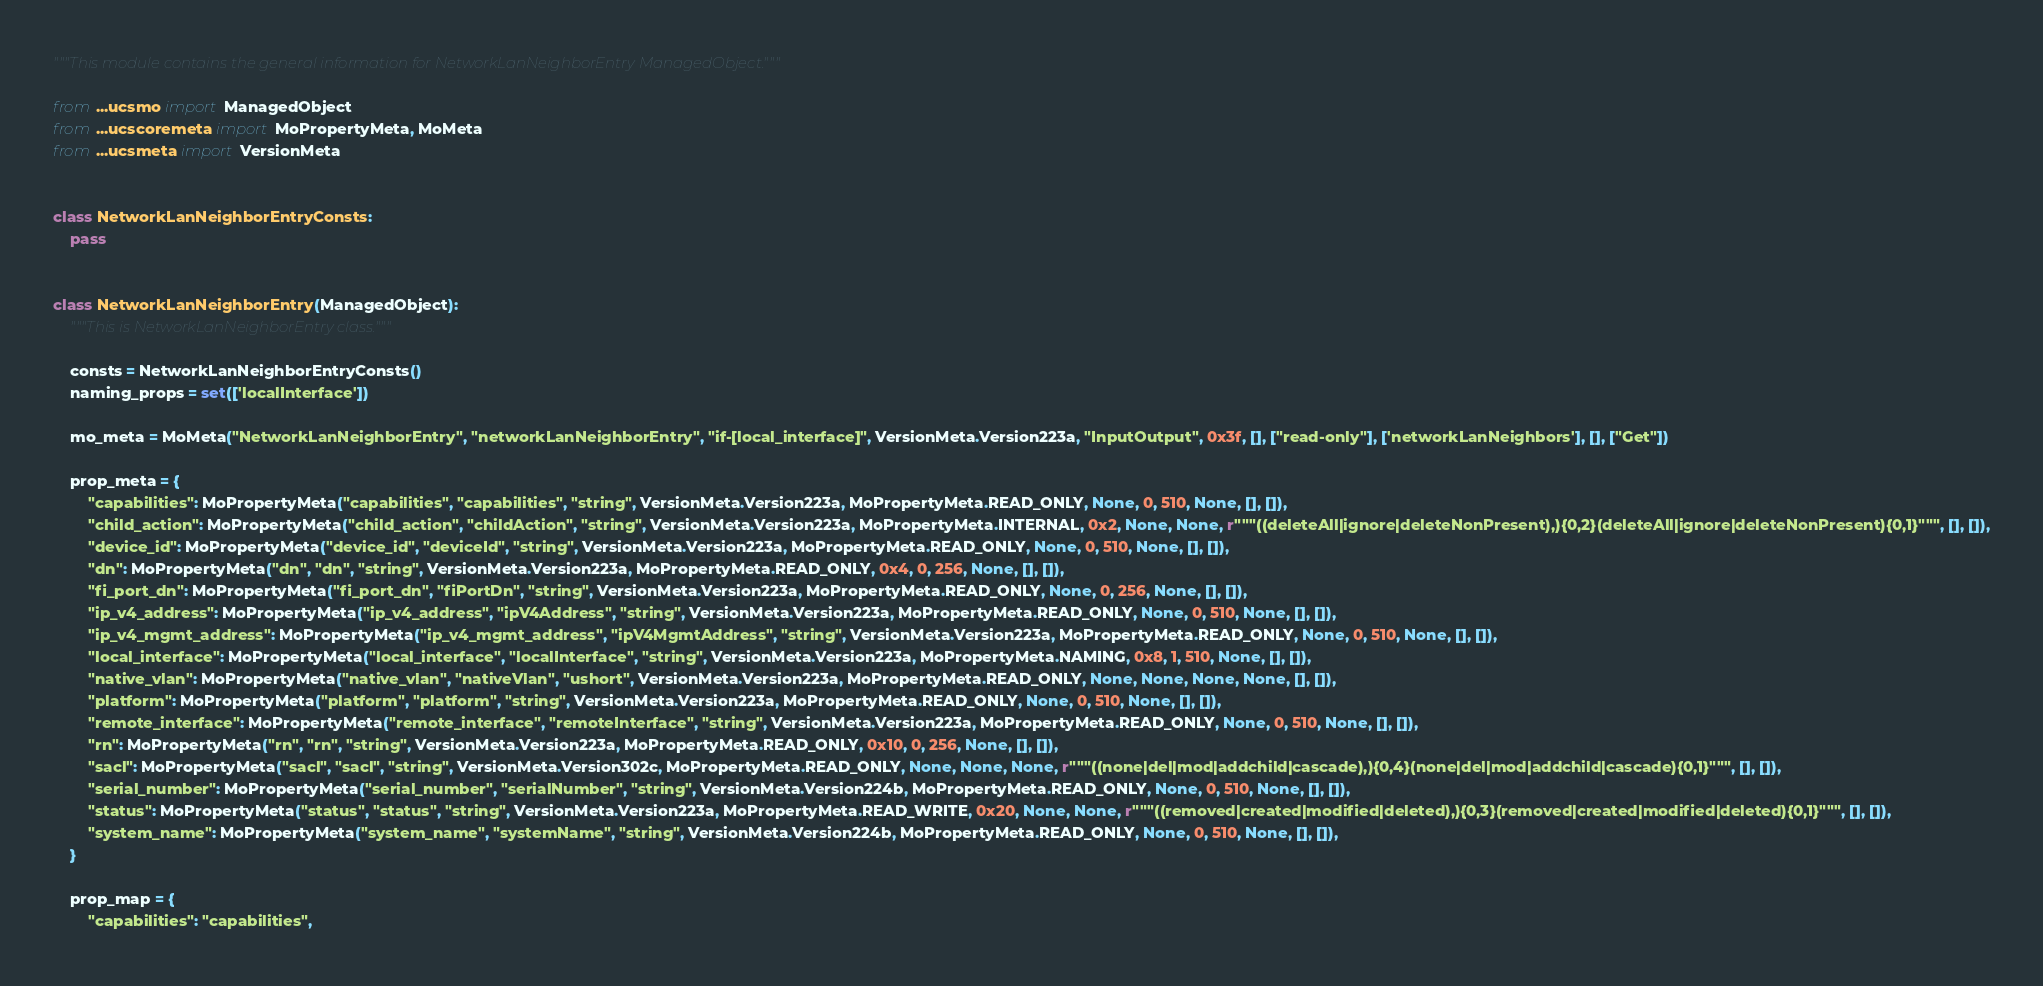<code> <loc_0><loc_0><loc_500><loc_500><_Python_>"""This module contains the general information for NetworkLanNeighborEntry ManagedObject."""

from ...ucsmo import ManagedObject
from ...ucscoremeta import MoPropertyMeta, MoMeta
from ...ucsmeta import VersionMeta


class NetworkLanNeighborEntryConsts:
    pass


class NetworkLanNeighborEntry(ManagedObject):
    """This is NetworkLanNeighborEntry class."""

    consts = NetworkLanNeighborEntryConsts()
    naming_props = set(['localInterface'])

    mo_meta = MoMeta("NetworkLanNeighborEntry", "networkLanNeighborEntry", "if-[local_interface]", VersionMeta.Version223a, "InputOutput", 0x3f, [], ["read-only"], ['networkLanNeighbors'], [], ["Get"])

    prop_meta = {
        "capabilities": MoPropertyMeta("capabilities", "capabilities", "string", VersionMeta.Version223a, MoPropertyMeta.READ_ONLY, None, 0, 510, None, [], []),
        "child_action": MoPropertyMeta("child_action", "childAction", "string", VersionMeta.Version223a, MoPropertyMeta.INTERNAL, 0x2, None, None, r"""((deleteAll|ignore|deleteNonPresent),){0,2}(deleteAll|ignore|deleteNonPresent){0,1}""", [], []),
        "device_id": MoPropertyMeta("device_id", "deviceId", "string", VersionMeta.Version223a, MoPropertyMeta.READ_ONLY, None, 0, 510, None, [], []),
        "dn": MoPropertyMeta("dn", "dn", "string", VersionMeta.Version223a, MoPropertyMeta.READ_ONLY, 0x4, 0, 256, None, [], []),
        "fi_port_dn": MoPropertyMeta("fi_port_dn", "fiPortDn", "string", VersionMeta.Version223a, MoPropertyMeta.READ_ONLY, None, 0, 256, None, [], []),
        "ip_v4_address": MoPropertyMeta("ip_v4_address", "ipV4Address", "string", VersionMeta.Version223a, MoPropertyMeta.READ_ONLY, None, 0, 510, None, [], []),
        "ip_v4_mgmt_address": MoPropertyMeta("ip_v4_mgmt_address", "ipV4MgmtAddress", "string", VersionMeta.Version223a, MoPropertyMeta.READ_ONLY, None, 0, 510, None, [], []),
        "local_interface": MoPropertyMeta("local_interface", "localInterface", "string", VersionMeta.Version223a, MoPropertyMeta.NAMING, 0x8, 1, 510, None, [], []),
        "native_vlan": MoPropertyMeta("native_vlan", "nativeVlan", "ushort", VersionMeta.Version223a, MoPropertyMeta.READ_ONLY, None, None, None, None, [], []),
        "platform": MoPropertyMeta("platform", "platform", "string", VersionMeta.Version223a, MoPropertyMeta.READ_ONLY, None, 0, 510, None, [], []),
        "remote_interface": MoPropertyMeta("remote_interface", "remoteInterface", "string", VersionMeta.Version223a, MoPropertyMeta.READ_ONLY, None, 0, 510, None, [], []),
        "rn": MoPropertyMeta("rn", "rn", "string", VersionMeta.Version223a, MoPropertyMeta.READ_ONLY, 0x10, 0, 256, None, [], []),
        "sacl": MoPropertyMeta("sacl", "sacl", "string", VersionMeta.Version302c, MoPropertyMeta.READ_ONLY, None, None, None, r"""((none|del|mod|addchild|cascade),){0,4}(none|del|mod|addchild|cascade){0,1}""", [], []),
        "serial_number": MoPropertyMeta("serial_number", "serialNumber", "string", VersionMeta.Version224b, MoPropertyMeta.READ_ONLY, None, 0, 510, None, [], []),
        "status": MoPropertyMeta("status", "status", "string", VersionMeta.Version223a, MoPropertyMeta.READ_WRITE, 0x20, None, None, r"""((removed|created|modified|deleted),){0,3}(removed|created|modified|deleted){0,1}""", [], []),
        "system_name": MoPropertyMeta("system_name", "systemName", "string", VersionMeta.Version224b, MoPropertyMeta.READ_ONLY, None, 0, 510, None, [], []),
    }

    prop_map = {
        "capabilities": "capabilities", </code> 